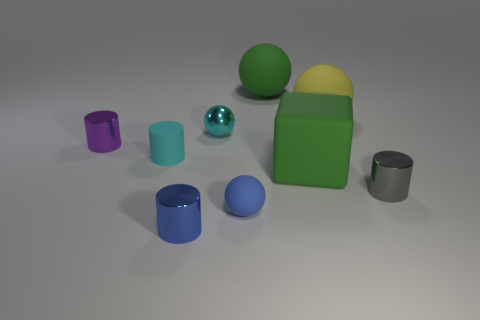Subtract all green balls. How many balls are left? 3 Add 1 purple shiny blocks. How many objects exist? 10 Subtract all blue cylinders. How many cylinders are left? 3 Subtract all gray spheres. Subtract all blue blocks. How many spheres are left? 4 Subtract 1 gray cylinders. How many objects are left? 8 Subtract all cubes. How many objects are left? 8 Subtract all tiny yellow metallic blocks. Subtract all cyan matte cylinders. How many objects are left? 8 Add 6 purple metal objects. How many purple metal objects are left? 7 Add 8 tiny blue things. How many tiny blue things exist? 10 